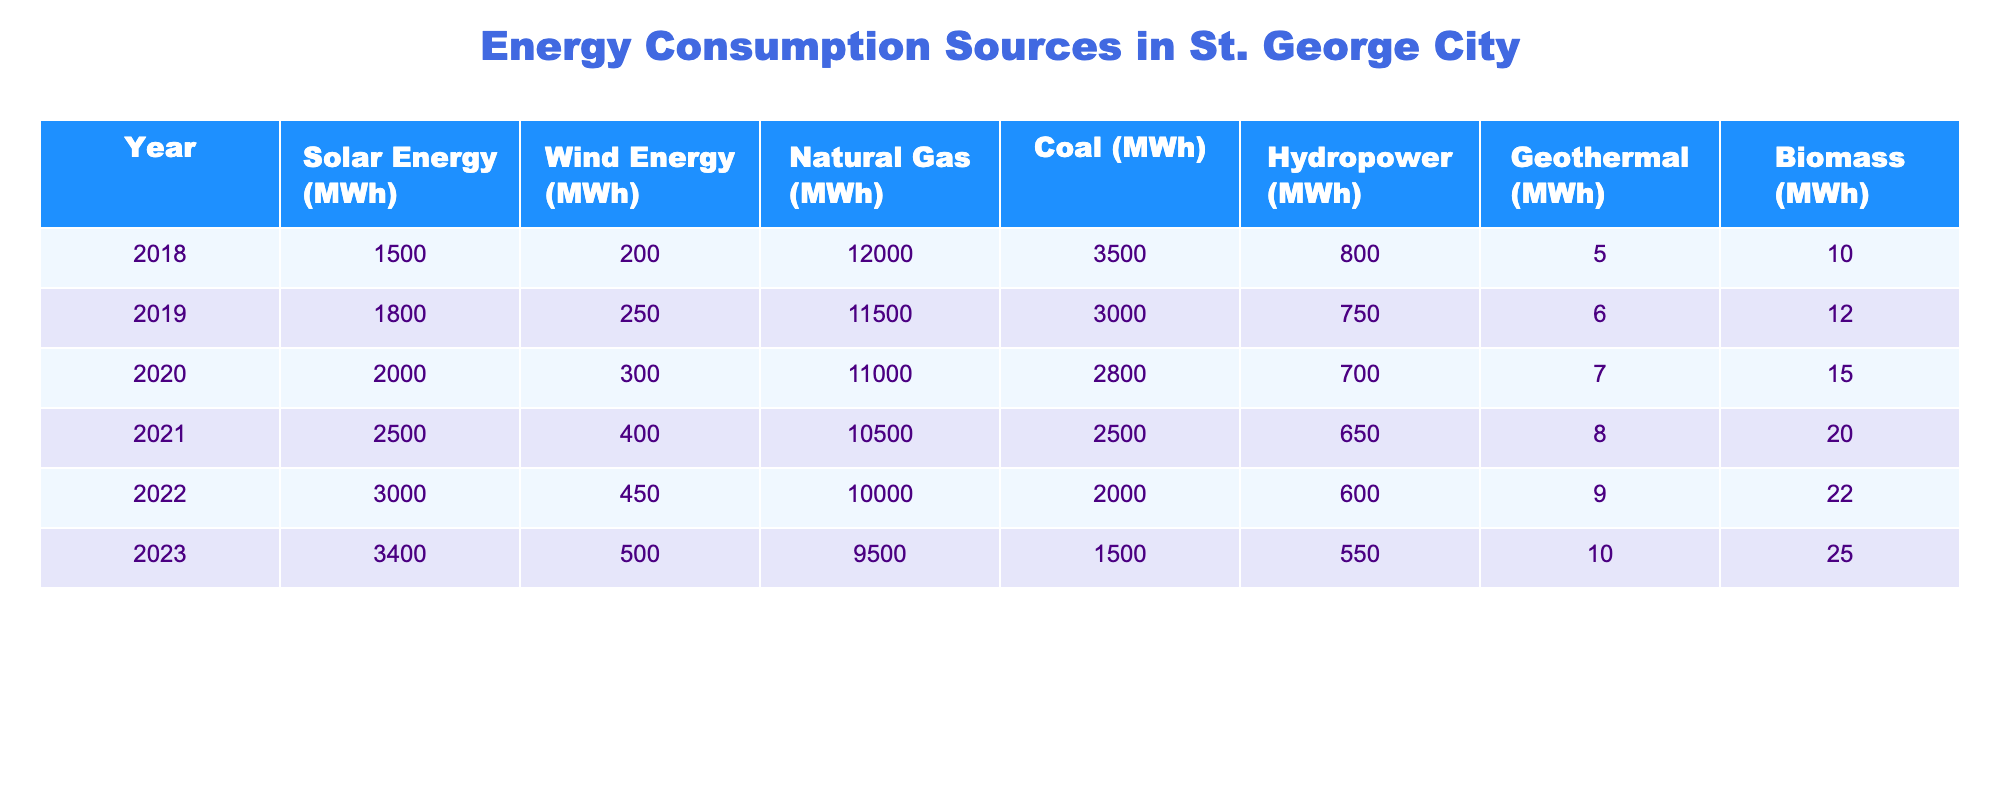What was the highest consumption of Solar Energy (MWh) recorded in the years? The highest consumption of Solar Energy occurred in 2023 with 3,400 MWh.
Answer: 3,400 MWh Which year had the least consumption of Coal (MWh)? The year with the least consumption of Coal was 2023 with only 1,500 MWh used.
Answer: 1,500 MWh What is the total consumption of Natural Gas over the years 2018 to 2023? To find the total consumption of Natural Gas, sum the values for each year: 12,000 + 11,500 + 11,000 + 10,500 + 10,000 + 9,500 = 64,500 MWh.
Answer: 64,500 MWh Did the consumption of Wind Energy increase every year from 2018 to 2023? Yes, the consumption of Wind Energy increased each year from 200 MWh in 2018 to 500 MWh in 2023.
Answer: Yes What was the average consumption of Hydropower from 2018 to 2023? The average consumption is calculated by summing the values (800 + 750 + 700 + 650 + 600 + 550 = 4,100) and dividing by the number of years (6): 4,100 / 6 = approximately 683.33 MWh.
Answer: 683.33 MWh In which year did Solar Energy first exceed 2,500 MWh? Solar Energy first exceeded 2,500 MWh in the year 2021 when it reached 2,500 MWh.
Answer: 2021 If we consider only the data from 2020 to 2023, what was the change in consumption of Biomass? The consumption of Biomass increased from 7 MWh in 2020 to 25 MWh in 2023. The change is 25 - 7 = 18 MWh.
Answer: 18 MWh Which source of energy had the highest decrease in consumption from 2018 to 2023? Coal had the highest decrease, going from 3,500 MWh in 2018 to 1,500 MWh in 2023, a loss of 2,000 MWh.
Answer: Coal What is the total energy consumption (sum of all sources) for the year 2022? Sum all the energy sources for 2022: 3,000 (Solar) + 450 (Wind) + 10,000 (Gas) + 2,000 (Coal) + 600 (Hydro) + 9 (Geothermal) + 22 (Biomass) = 15,081 MWh.
Answer: 15,081 MWh How much more Natural Gas was consumed in 2019 compared to 2023? Natural Gas consumption in 2019 was 11,500 MWh and in 2023 it was 9,500 MWh. The difference is 11,500 - 9,500 = 2,000 MWh.
Answer: 2,000 MWh 